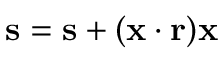Convert formula to latex. <formula><loc_0><loc_0><loc_500><loc_500>s = s + ( x \cdot r ) x</formula> 